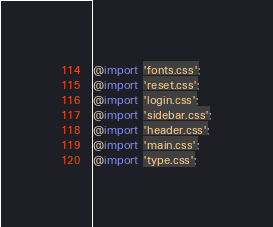Convert code to text. <code><loc_0><loc_0><loc_500><loc_500><_CSS_>@import 'fonts.css';
@import 'reset.css';
@import 'login.css';
@import 'sidebar.css';
@import 'header.css';
@import 'main.css';
@import 'type.css';
</code> 